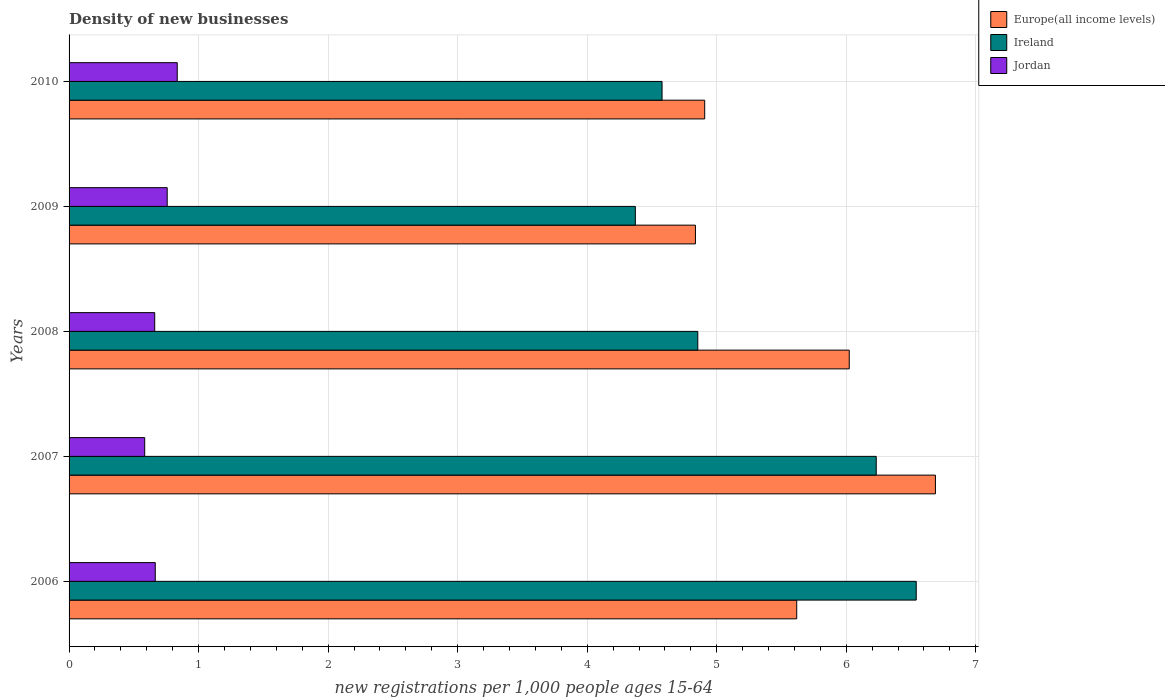Are the number of bars per tick equal to the number of legend labels?
Your response must be concise. Yes. How many bars are there on the 4th tick from the bottom?
Make the answer very short. 3. What is the number of new registrations in Ireland in 2009?
Make the answer very short. 4.37. Across all years, what is the maximum number of new registrations in Europe(all income levels)?
Give a very brief answer. 6.69. Across all years, what is the minimum number of new registrations in Europe(all income levels)?
Your answer should be compact. 4.84. In which year was the number of new registrations in Ireland minimum?
Offer a terse response. 2009. What is the total number of new registrations in Jordan in the graph?
Give a very brief answer. 3.5. What is the difference between the number of new registrations in Ireland in 2008 and that in 2010?
Offer a terse response. 0.28. What is the difference between the number of new registrations in Ireland in 2006 and the number of new registrations in Jordan in 2010?
Provide a short and direct response. 5.71. What is the average number of new registrations in Europe(all income levels) per year?
Your answer should be very brief. 5.61. In the year 2006, what is the difference between the number of new registrations in Jordan and number of new registrations in Europe(all income levels)?
Provide a short and direct response. -4.95. What is the ratio of the number of new registrations in Ireland in 2006 to that in 2009?
Give a very brief answer. 1.5. Is the number of new registrations in Jordan in 2006 less than that in 2009?
Give a very brief answer. Yes. Is the difference between the number of new registrations in Jordan in 2008 and 2010 greater than the difference between the number of new registrations in Europe(all income levels) in 2008 and 2010?
Keep it short and to the point. No. What is the difference between the highest and the second highest number of new registrations in Ireland?
Your answer should be very brief. 0.31. What is the difference between the highest and the lowest number of new registrations in Ireland?
Keep it short and to the point. 2.17. What does the 1st bar from the top in 2010 represents?
Your answer should be very brief. Jordan. What does the 2nd bar from the bottom in 2006 represents?
Provide a short and direct response. Ireland. Is it the case that in every year, the sum of the number of new registrations in Ireland and number of new registrations in Europe(all income levels) is greater than the number of new registrations in Jordan?
Keep it short and to the point. Yes. How many bars are there?
Your answer should be compact. 15. Are all the bars in the graph horizontal?
Provide a short and direct response. Yes. What is the difference between two consecutive major ticks on the X-axis?
Provide a short and direct response. 1. Does the graph contain any zero values?
Your answer should be compact. No. How are the legend labels stacked?
Your answer should be compact. Vertical. What is the title of the graph?
Make the answer very short. Density of new businesses. What is the label or title of the X-axis?
Make the answer very short. New registrations per 1,0 people ages 15-64. What is the label or title of the Y-axis?
Ensure brevity in your answer.  Years. What is the new registrations per 1,000 people ages 15-64 in Europe(all income levels) in 2006?
Provide a succinct answer. 5.62. What is the new registrations per 1,000 people ages 15-64 in Ireland in 2006?
Provide a succinct answer. 6.54. What is the new registrations per 1,000 people ages 15-64 in Jordan in 2006?
Provide a short and direct response. 0.67. What is the new registrations per 1,000 people ages 15-64 in Europe(all income levels) in 2007?
Your answer should be compact. 6.69. What is the new registrations per 1,000 people ages 15-64 of Ireland in 2007?
Your answer should be very brief. 6.23. What is the new registrations per 1,000 people ages 15-64 in Jordan in 2007?
Keep it short and to the point. 0.58. What is the new registrations per 1,000 people ages 15-64 in Europe(all income levels) in 2008?
Offer a very short reply. 6.02. What is the new registrations per 1,000 people ages 15-64 in Ireland in 2008?
Your response must be concise. 4.85. What is the new registrations per 1,000 people ages 15-64 in Jordan in 2008?
Offer a terse response. 0.66. What is the new registrations per 1,000 people ages 15-64 in Europe(all income levels) in 2009?
Make the answer very short. 4.84. What is the new registrations per 1,000 people ages 15-64 in Ireland in 2009?
Provide a succinct answer. 4.37. What is the new registrations per 1,000 people ages 15-64 of Jordan in 2009?
Make the answer very short. 0.76. What is the new registrations per 1,000 people ages 15-64 of Europe(all income levels) in 2010?
Provide a succinct answer. 4.91. What is the new registrations per 1,000 people ages 15-64 in Ireland in 2010?
Your answer should be very brief. 4.58. What is the new registrations per 1,000 people ages 15-64 in Jordan in 2010?
Provide a succinct answer. 0.84. Across all years, what is the maximum new registrations per 1,000 people ages 15-64 of Europe(all income levels)?
Provide a succinct answer. 6.69. Across all years, what is the maximum new registrations per 1,000 people ages 15-64 in Ireland?
Give a very brief answer. 6.54. Across all years, what is the maximum new registrations per 1,000 people ages 15-64 of Jordan?
Provide a short and direct response. 0.84. Across all years, what is the minimum new registrations per 1,000 people ages 15-64 of Europe(all income levels)?
Keep it short and to the point. 4.84. Across all years, what is the minimum new registrations per 1,000 people ages 15-64 of Ireland?
Keep it short and to the point. 4.37. Across all years, what is the minimum new registrations per 1,000 people ages 15-64 of Jordan?
Keep it short and to the point. 0.58. What is the total new registrations per 1,000 people ages 15-64 in Europe(all income levels) in the graph?
Offer a very short reply. 28.07. What is the total new registrations per 1,000 people ages 15-64 in Ireland in the graph?
Offer a terse response. 26.58. What is the total new registrations per 1,000 people ages 15-64 in Jordan in the graph?
Offer a terse response. 3.5. What is the difference between the new registrations per 1,000 people ages 15-64 of Europe(all income levels) in 2006 and that in 2007?
Keep it short and to the point. -1.07. What is the difference between the new registrations per 1,000 people ages 15-64 of Ireland in 2006 and that in 2007?
Your response must be concise. 0.31. What is the difference between the new registrations per 1,000 people ages 15-64 of Jordan in 2006 and that in 2007?
Give a very brief answer. 0.08. What is the difference between the new registrations per 1,000 people ages 15-64 of Europe(all income levels) in 2006 and that in 2008?
Provide a short and direct response. -0.41. What is the difference between the new registrations per 1,000 people ages 15-64 of Ireland in 2006 and that in 2008?
Make the answer very short. 1.69. What is the difference between the new registrations per 1,000 people ages 15-64 in Jordan in 2006 and that in 2008?
Provide a succinct answer. 0. What is the difference between the new registrations per 1,000 people ages 15-64 of Europe(all income levels) in 2006 and that in 2009?
Your response must be concise. 0.78. What is the difference between the new registrations per 1,000 people ages 15-64 of Ireland in 2006 and that in 2009?
Give a very brief answer. 2.17. What is the difference between the new registrations per 1,000 people ages 15-64 of Jordan in 2006 and that in 2009?
Your answer should be very brief. -0.09. What is the difference between the new registrations per 1,000 people ages 15-64 in Europe(all income levels) in 2006 and that in 2010?
Give a very brief answer. 0.71. What is the difference between the new registrations per 1,000 people ages 15-64 of Ireland in 2006 and that in 2010?
Provide a succinct answer. 1.96. What is the difference between the new registrations per 1,000 people ages 15-64 in Jordan in 2006 and that in 2010?
Your answer should be compact. -0.17. What is the difference between the new registrations per 1,000 people ages 15-64 of Europe(all income levels) in 2007 and that in 2008?
Give a very brief answer. 0.67. What is the difference between the new registrations per 1,000 people ages 15-64 in Ireland in 2007 and that in 2008?
Give a very brief answer. 1.38. What is the difference between the new registrations per 1,000 people ages 15-64 of Jordan in 2007 and that in 2008?
Give a very brief answer. -0.08. What is the difference between the new registrations per 1,000 people ages 15-64 of Europe(all income levels) in 2007 and that in 2009?
Your response must be concise. 1.85. What is the difference between the new registrations per 1,000 people ages 15-64 of Ireland in 2007 and that in 2009?
Keep it short and to the point. 1.86. What is the difference between the new registrations per 1,000 people ages 15-64 of Jordan in 2007 and that in 2009?
Provide a short and direct response. -0.17. What is the difference between the new registrations per 1,000 people ages 15-64 of Europe(all income levels) in 2007 and that in 2010?
Make the answer very short. 1.78. What is the difference between the new registrations per 1,000 people ages 15-64 of Ireland in 2007 and that in 2010?
Give a very brief answer. 1.65. What is the difference between the new registrations per 1,000 people ages 15-64 in Jordan in 2007 and that in 2010?
Ensure brevity in your answer.  -0.25. What is the difference between the new registrations per 1,000 people ages 15-64 of Europe(all income levels) in 2008 and that in 2009?
Your answer should be compact. 1.19. What is the difference between the new registrations per 1,000 people ages 15-64 of Ireland in 2008 and that in 2009?
Provide a succinct answer. 0.48. What is the difference between the new registrations per 1,000 people ages 15-64 in Jordan in 2008 and that in 2009?
Ensure brevity in your answer.  -0.1. What is the difference between the new registrations per 1,000 people ages 15-64 in Europe(all income levels) in 2008 and that in 2010?
Your answer should be compact. 1.12. What is the difference between the new registrations per 1,000 people ages 15-64 in Ireland in 2008 and that in 2010?
Give a very brief answer. 0.28. What is the difference between the new registrations per 1,000 people ages 15-64 of Jordan in 2008 and that in 2010?
Give a very brief answer. -0.17. What is the difference between the new registrations per 1,000 people ages 15-64 of Europe(all income levels) in 2009 and that in 2010?
Your answer should be compact. -0.07. What is the difference between the new registrations per 1,000 people ages 15-64 of Ireland in 2009 and that in 2010?
Make the answer very short. -0.21. What is the difference between the new registrations per 1,000 people ages 15-64 in Jordan in 2009 and that in 2010?
Offer a very short reply. -0.08. What is the difference between the new registrations per 1,000 people ages 15-64 in Europe(all income levels) in 2006 and the new registrations per 1,000 people ages 15-64 in Ireland in 2007?
Your answer should be very brief. -0.61. What is the difference between the new registrations per 1,000 people ages 15-64 in Europe(all income levels) in 2006 and the new registrations per 1,000 people ages 15-64 in Jordan in 2007?
Make the answer very short. 5.03. What is the difference between the new registrations per 1,000 people ages 15-64 in Ireland in 2006 and the new registrations per 1,000 people ages 15-64 in Jordan in 2007?
Your answer should be very brief. 5.96. What is the difference between the new registrations per 1,000 people ages 15-64 of Europe(all income levels) in 2006 and the new registrations per 1,000 people ages 15-64 of Ireland in 2008?
Your answer should be compact. 0.76. What is the difference between the new registrations per 1,000 people ages 15-64 in Europe(all income levels) in 2006 and the new registrations per 1,000 people ages 15-64 in Jordan in 2008?
Offer a very short reply. 4.96. What is the difference between the new registrations per 1,000 people ages 15-64 of Ireland in 2006 and the new registrations per 1,000 people ages 15-64 of Jordan in 2008?
Your answer should be very brief. 5.88. What is the difference between the new registrations per 1,000 people ages 15-64 in Europe(all income levels) in 2006 and the new registrations per 1,000 people ages 15-64 in Ireland in 2009?
Ensure brevity in your answer.  1.25. What is the difference between the new registrations per 1,000 people ages 15-64 of Europe(all income levels) in 2006 and the new registrations per 1,000 people ages 15-64 of Jordan in 2009?
Offer a very short reply. 4.86. What is the difference between the new registrations per 1,000 people ages 15-64 of Ireland in 2006 and the new registrations per 1,000 people ages 15-64 of Jordan in 2009?
Provide a short and direct response. 5.78. What is the difference between the new registrations per 1,000 people ages 15-64 of Europe(all income levels) in 2006 and the new registrations per 1,000 people ages 15-64 of Ireland in 2010?
Your answer should be very brief. 1.04. What is the difference between the new registrations per 1,000 people ages 15-64 in Europe(all income levels) in 2006 and the new registrations per 1,000 people ages 15-64 in Jordan in 2010?
Provide a short and direct response. 4.78. What is the difference between the new registrations per 1,000 people ages 15-64 in Ireland in 2006 and the new registrations per 1,000 people ages 15-64 in Jordan in 2010?
Offer a terse response. 5.71. What is the difference between the new registrations per 1,000 people ages 15-64 of Europe(all income levels) in 2007 and the new registrations per 1,000 people ages 15-64 of Ireland in 2008?
Make the answer very short. 1.83. What is the difference between the new registrations per 1,000 people ages 15-64 of Europe(all income levels) in 2007 and the new registrations per 1,000 people ages 15-64 of Jordan in 2008?
Ensure brevity in your answer.  6.03. What is the difference between the new registrations per 1,000 people ages 15-64 of Ireland in 2007 and the new registrations per 1,000 people ages 15-64 of Jordan in 2008?
Your answer should be very brief. 5.57. What is the difference between the new registrations per 1,000 people ages 15-64 of Europe(all income levels) in 2007 and the new registrations per 1,000 people ages 15-64 of Ireland in 2009?
Offer a terse response. 2.32. What is the difference between the new registrations per 1,000 people ages 15-64 in Europe(all income levels) in 2007 and the new registrations per 1,000 people ages 15-64 in Jordan in 2009?
Provide a succinct answer. 5.93. What is the difference between the new registrations per 1,000 people ages 15-64 in Ireland in 2007 and the new registrations per 1,000 people ages 15-64 in Jordan in 2009?
Offer a very short reply. 5.47. What is the difference between the new registrations per 1,000 people ages 15-64 in Europe(all income levels) in 2007 and the new registrations per 1,000 people ages 15-64 in Ireland in 2010?
Your response must be concise. 2.11. What is the difference between the new registrations per 1,000 people ages 15-64 in Europe(all income levels) in 2007 and the new registrations per 1,000 people ages 15-64 in Jordan in 2010?
Offer a very short reply. 5.85. What is the difference between the new registrations per 1,000 people ages 15-64 in Ireland in 2007 and the new registrations per 1,000 people ages 15-64 in Jordan in 2010?
Your answer should be very brief. 5.4. What is the difference between the new registrations per 1,000 people ages 15-64 in Europe(all income levels) in 2008 and the new registrations per 1,000 people ages 15-64 in Ireland in 2009?
Make the answer very short. 1.65. What is the difference between the new registrations per 1,000 people ages 15-64 of Europe(all income levels) in 2008 and the new registrations per 1,000 people ages 15-64 of Jordan in 2009?
Your answer should be very brief. 5.27. What is the difference between the new registrations per 1,000 people ages 15-64 of Ireland in 2008 and the new registrations per 1,000 people ages 15-64 of Jordan in 2009?
Your response must be concise. 4.1. What is the difference between the new registrations per 1,000 people ages 15-64 of Europe(all income levels) in 2008 and the new registrations per 1,000 people ages 15-64 of Ireland in 2010?
Your answer should be very brief. 1.45. What is the difference between the new registrations per 1,000 people ages 15-64 in Europe(all income levels) in 2008 and the new registrations per 1,000 people ages 15-64 in Jordan in 2010?
Offer a very short reply. 5.19. What is the difference between the new registrations per 1,000 people ages 15-64 of Ireland in 2008 and the new registrations per 1,000 people ages 15-64 of Jordan in 2010?
Provide a short and direct response. 4.02. What is the difference between the new registrations per 1,000 people ages 15-64 in Europe(all income levels) in 2009 and the new registrations per 1,000 people ages 15-64 in Ireland in 2010?
Give a very brief answer. 0.26. What is the difference between the new registrations per 1,000 people ages 15-64 in Europe(all income levels) in 2009 and the new registrations per 1,000 people ages 15-64 in Jordan in 2010?
Offer a terse response. 4. What is the difference between the new registrations per 1,000 people ages 15-64 of Ireland in 2009 and the new registrations per 1,000 people ages 15-64 of Jordan in 2010?
Your answer should be compact. 3.54. What is the average new registrations per 1,000 people ages 15-64 in Europe(all income levels) per year?
Keep it short and to the point. 5.61. What is the average new registrations per 1,000 people ages 15-64 of Ireland per year?
Provide a succinct answer. 5.32. What is the average new registrations per 1,000 people ages 15-64 of Jordan per year?
Offer a terse response. 0.7. In the year 2006, what is the difference between the new registrations per 1,000 people ages 15-64 of Europe(all income levels) and new registrations per 1,000 people ages 15-64 of Ireland?
Give a very brief answer. -0.92. In the year 2006, what is the difference between the new registrations per 1,000 people ages 15-64 of Europe(all income levels) and new registrations per 1,000 people ages 15-64 of Jordan?
Give a very brief answer. 4.95. In the year 2006, what is the difference between the new registrations per 1,000 people ages 15-64 of Ireland and new registrations per 1,000 people ages 15-64 of Jordan?
Provide a succinct answer. 5.87. In the year 2007, what is the difference between the new registrations per 1,000 people ages 15-64 in Europe(all income levels) and new registrations per 1,000 people ages 15-64 in Ireland?
Provide a short and direct response. 0.46. In the year 2007, what is the difference between the new registrations per 1,000 people ages 15-64 of Europe(all income levels) and new registrations per 1,000 people ages 15-64 of Jordan?
Give a very brief answer. 6.1. In the year 2007, what is the difference between the new registrations per 1,000 people ages 15-64 of Ireland and new registrations per 1,000 people ages 15-64 of Jordan?
Offer a very short reply. 5.65. In the year 2008, what is the difference between the new registrations per 1,000 people ages 15-64 in Europe(all income levels) and new registrations per 1,000 people ages 15-64 in Ireland?
Provide a short and direct response. 1.17. In the year 2008, what is the difference between the new registrations per 1,000 people ages 15-64 of Europe(all income levels) and new registrations per 1,000 people ages 15-64 of Jordan?
Your answer should be compact. 5.36. In the year 2008, what is the difference between the new registrations per 1,000 people ages 15-64 in Ireland and new registrations per 1,000 people ages 15-64 in Jordan?
Your answer should be compact. 4.19. In the year 2009, what is the difference between the new registrations per 1,000 people ages 15-64 of Europe(all income levels) and new registrations per 1,000 people ages 15-64 of Ireland?
Offer a terse response. 0.46. In the year 2009, what is the difference between the new registrations per 1,000 people ages 15-64 of Europe(all income levels) and new registrations per 1,000 people ages 15-64 of Jordan?
Your answer should be very brief. 4.08. In the year 2009, what is the difference between the new registrations per 1,000 people ages 15-64 in Ireland and new registrations per 1,000 people ages 15-64 in Jordan?
Keep it short and to the point. 3.61. In the year 2010, what is the difference between the new registrations per 1,000 people ages 15-64 in Europe(all income levels) and new registrations per 1,000 people ages 15-64 in Ireland?
Provide a succinct answer. 0.33. In the year 2010, what is the difference between the new registrations per 1,000 people ages 15-64 of Europe(all income levels) and new registrations per 1,000 people ages 15-64 of Jordan?
Your response must be concise. 4.07. In the year 2010, what is the difference between the new registrations per 1,000 people ages 15-64 in Ireland and new registrations per 1,000 people ages 15-64 in Jordan?
Make the answer very short. 3.74. What is the ratio of the new registrations per 1,000 people ages 15-64 in Europe(all income levels) in 2006 to that in 2007?
Keep it short and to the point. 0.84. What is the ratio of the new registrations per 1,000 people ages 15-64 of Ireland in 2006 to that in 2007?
Offer a very short reply. 1.05. What is the ratio of the new registrations per 1,000 people ages 15-64 in Jordan in 2006 to that in 2007?
Offer a very short reply. 1.14. What is the ratio of the new registrations per 1,000 people ages 15-64 in Europe(all income levels) in 2006 to that in 2008?
Make the answer very short. 0.93. What is the ratio of the new registrations per 1,000 people ages 15-64 in Ireland in 2006 to that in 2008?
Ensure brevity in your answer.  1.35. What is the ratio of the new registrations per 1,000 people ages 15-64 in Jordan in 2006 to that in 2008?
Offer a very short reply. 1.01. What is the ratio of the new registrations per 1,000 people ages 15-64 in Europe(all income levels) in 2006 to that in 2009?
Make the answer very short. 1.16. What is the ratio of the new registrations per 1,000 people ages 15-64 of Ireland in 2006 to that in 2009?
Offer a very short reply. 1.5. What is the ratio of the new registrations per 1,000 people ages 15-64 of Jordan in 2006 to that in 2009?
Keep it short and to the point. 0.88. What is the ratio of the new registrations per 1,000 people ages 15-64 in Europe(all income levels) in 2006 to that in 2010?
Provide a short and direct response. 1.14. What is the ratio of the new registrations per 1,000 people ages 15-64 in Ireland in 2006 to that in 2010?
Make the answer very short. 1.43. What is the ratio of the new registrations per 1,000 people ages 15-64 of Jordan in 2006 to that in 2010?
Your response must be concise. 0.8. What is the ratio of the new registrations per 1,000 people ages 15-64 in Europe(all income levels) in 2007 to that in 2008?
Provide a succinct answer. 1.11. What is the ratio of the new registrations per 1,000 people ages 15-64 of Ireland in 2007 to that in 2008?
Your answer should be compact. 1.28. What is the ratio of the new registrations per 1,000 people ages 15-64 in Jordan in 2007 to that in 2008?
Your response must be concise. 0.88. What is the ratio of the new registrations per 1,000 people ages 15-64 in Europe(all income levels) in 2007 to that in 2009?
Your answer should be compact. 1.38. What is the ratio of the new registrations per 1,000 people ages 15-64 in Ireland in 2007 to that in 2009?
Offer a very short reply. 1.43. What is the ratio of the new registrations per 1,000 people ages 15-64 of Jordan in 2007 to that in 2009?
Provide a short and direct response. 0.77. What is the ratio of the new registrations per 1,000 people ages 15-64 of Europe(all income levels) in 2007 to that in 2010?
Offer a very short reply. 1.36. What is the ratio of the new registrations per 1,000 people ages 15-64 in Ireland in 2007 to that in 2010?
Offer a terse response. 1.36. What is the ratio of the new registrations per 1,000 people ages 15-64 of Jordan in 2007 to that in 2010?
Keep it short and to the point. 0.7. What is the ratio of the new registrations per 1,000 people ages 15-64 in Europe(all income levels) in 2008 to that in 2009?
Ensure brevity in your answer.  1.25. What is the ratio of the new registrations per 1,000 people ages 15-64 of Ireland in 2008 to that in 2009?
Make the answer very short. 1.11. What is the ratio of the new registrations per 1,000 people ages 15-64 of Jordan in 2008 to that in 2009?
Your answer should be compact. 0.87. What is the ratio of the new registrations per 1,000 people ages 15-64 in Europe(all income levels) in 2008 to that in 2010?
Your answer should be compact. 1.23. What is the ratio of the new registrations per 1,000 people ages 15-64 of Ireland in 2008 to that in 2010?
Your answer should be very brief. 1.06. What is the ratio of the new registrations per 1,000 people ages 15-64 in Jordan in 2008 to that in 2010?
Ensure brevity in your answer.  0.79. What is the ratio of the new registrations per 1,000 people ages 15-64 in Europe(all income levels) in 2009 to that in 2010?
Your answer should be very brief. 0.99. What is the ratio of the new registrations per 1,000 people ages 15-64 of Ireland in 2009 to that in 2010?
Offer a terse response. 0.95. What is the ratio of the new registrations per 1,000 people ages 15-64 of Jordan in 2009 to that in 2010?
Provide a short and direct response. 0.91. What is the difference between the highest and the second highest new registrations per 1,000 people ages 15-64 of Europe(all income levels)?
Provide a short and direct response. 0.67. What is the difference between the highest and the second highest new registrations per 1,000 people ages 15-64 of Ireland?
Your answer should be very brief. 0.31. What is the difference between the highest and the second highest new registrations per 1,000 people ages 15-64 of Jordan?
Your answer should be compact. 0.08. What is the difference between the highest and the lowest new registrations per 1,000 people ages 15-64 of Europe(all income levels)?
Provide a succinct answer. 1.85. What is the difference between the highest and the lowest new registrations per 1,000 people ages 15-64 in Ireland?
Your answer should be compact. 2.17. What is the difference between the highest and the lowest new registrations per 1,000 people ages 15-64 in Jordan?
Offer a terse response. 0.25. 